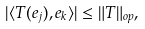Convert formula to latex. <formula><loc_0><loc_0><loc_500><loc_500>| \langle T ( e _ { j } ) , e _ { k } \rangle | \leq \| T \| _ { o p } ,</formula> 